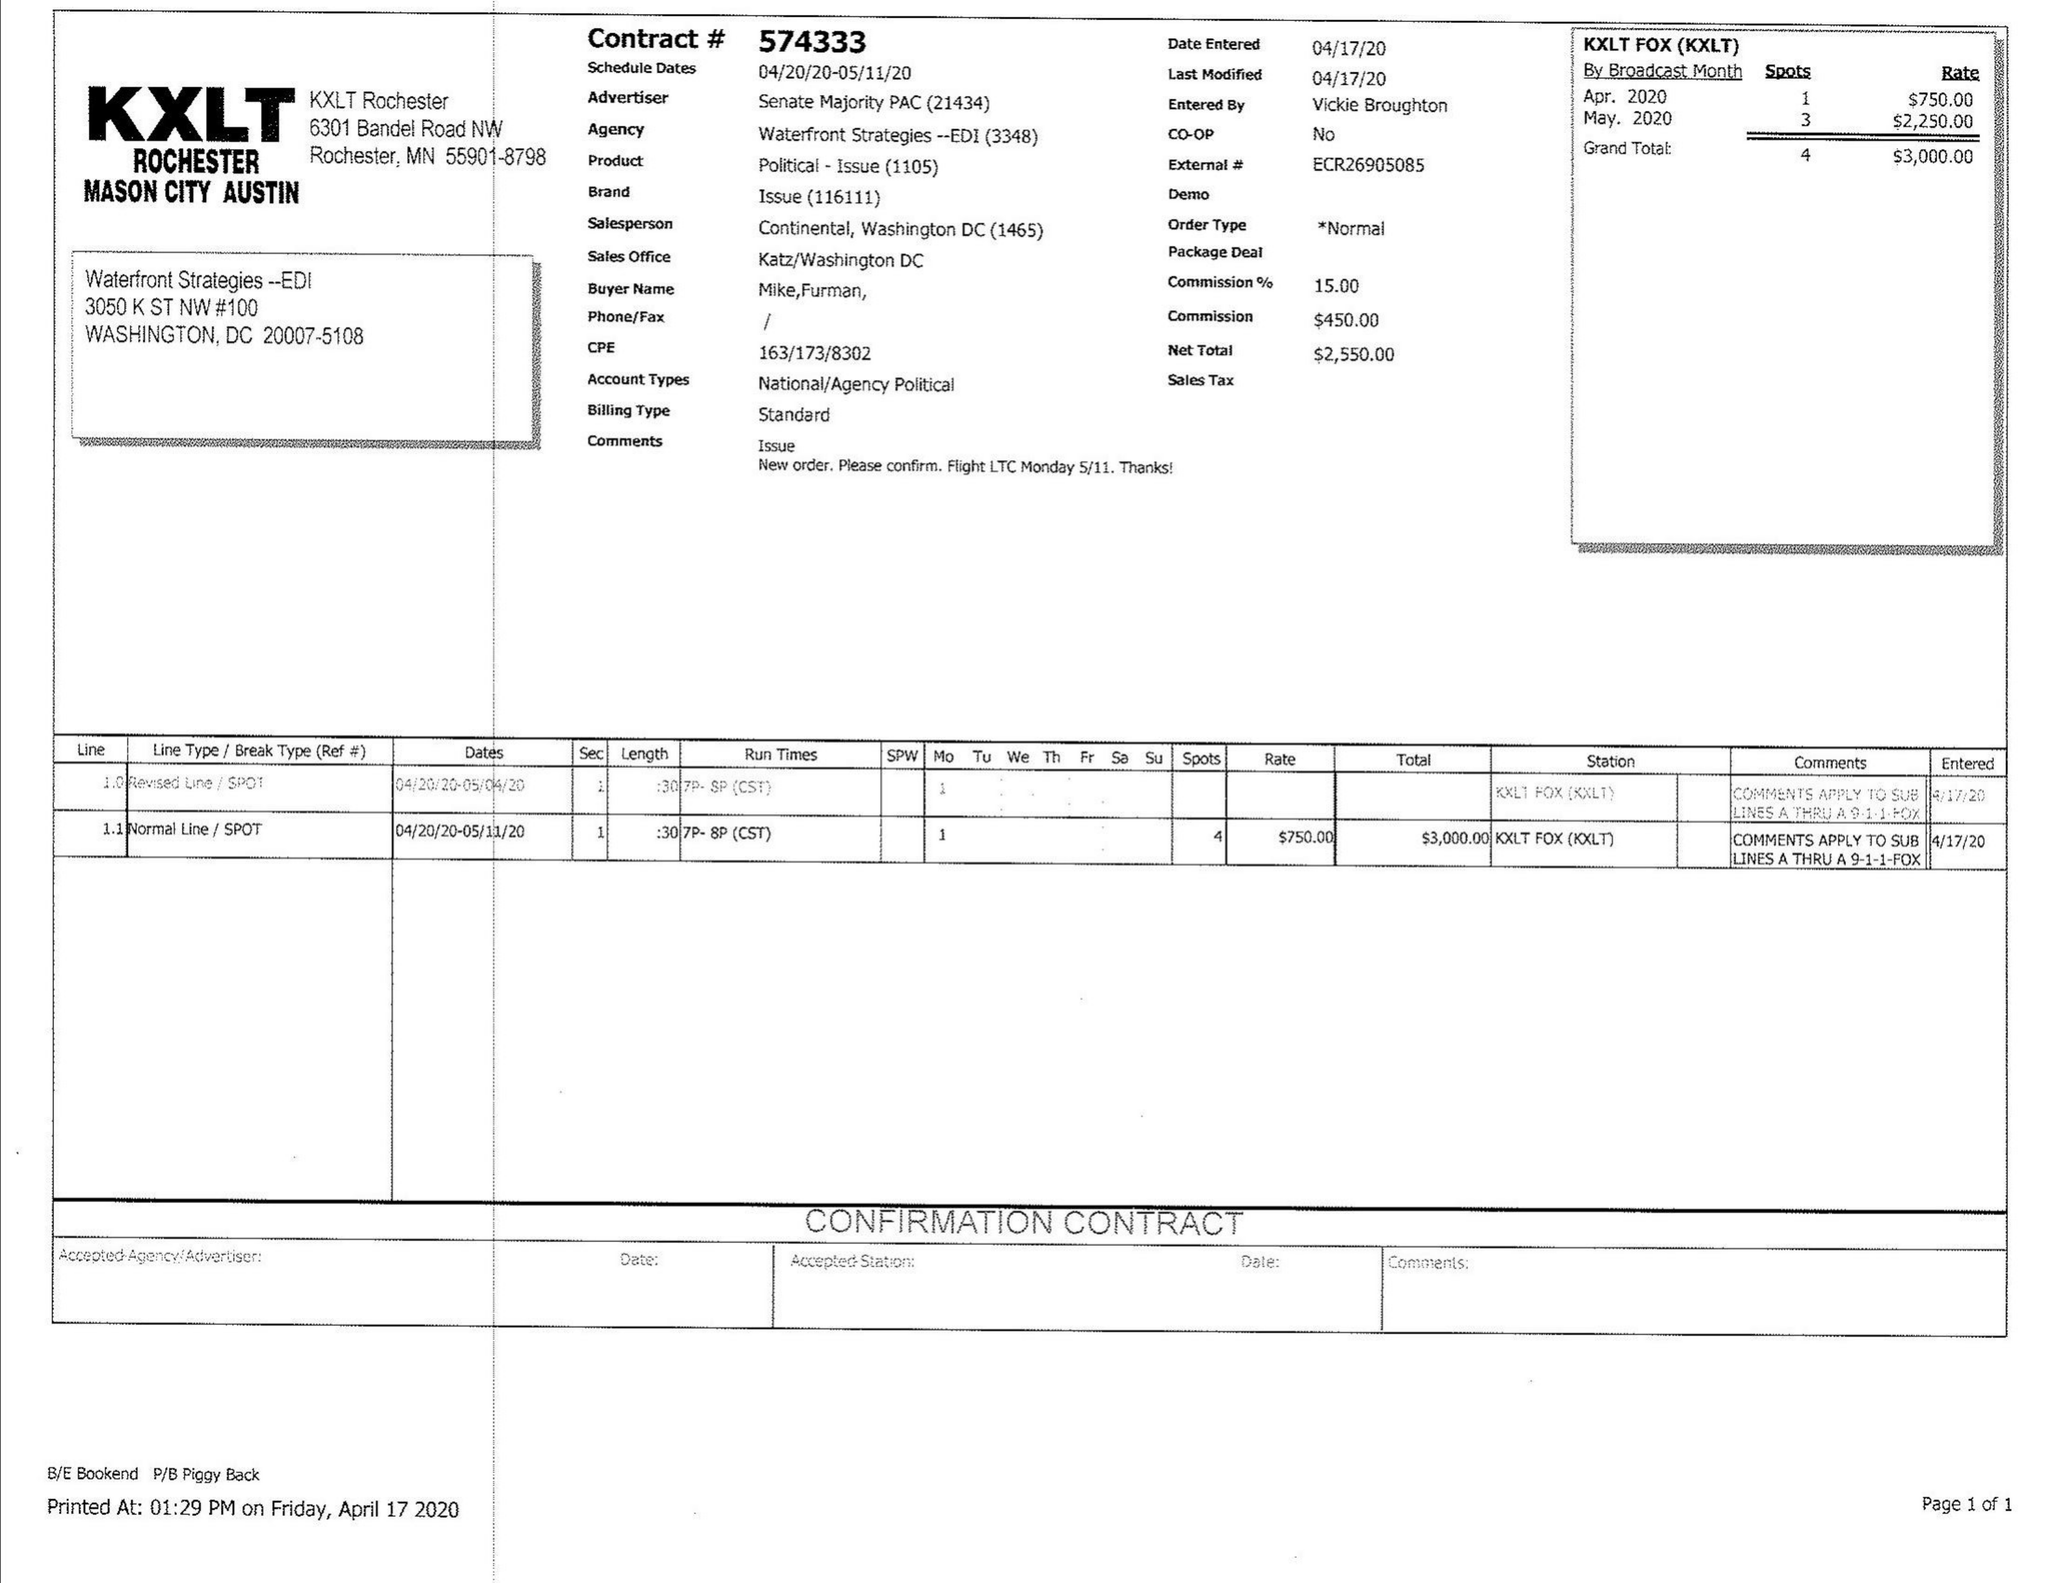What is the value for the contract_num?
Answer the question using a single word or phrase. 574333 